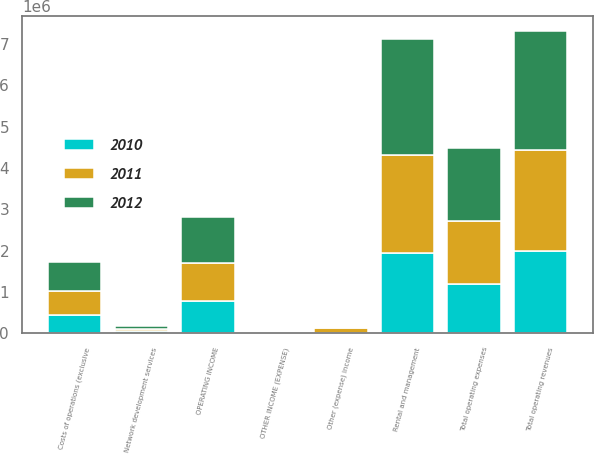<chart> <loc_0><loc_0><loc_500><loc_500><stacked_bar_chart><ecel><fcel>Rental and management<fcel>Network development services<fcel>Total operating revenues<fcel>Costs of operations (exclusive<fcel>Total operating expenses<fcel>OPERATING INCOME<fcel>OTHER INCOME (EXPENSE)<fcel>Other (expense) income<nl><fcel>2012<fcel>2.80349e+06<fcel>72470<fcel>2.87596e+06<fcel>686681<fcel>1.75624e+06<fcel>1.11972e+06<fcel>14258<fcel>38300<nl><fcel>2011<fcel>2.38618e+06<fcel>57347<fcel>2.44353e+06<fcel>590272<fcel>1.5234e+06<fcel>920132<fcel>14214<fcel>122975<nl><fcel>2010<fcel>1.93637e+06<fcel>48962<fcel>1.98534e+06<fcel>447629<fcel>1.20096e+06<fcel>784378<fcel>14212<fcel>315<nl></chart> 